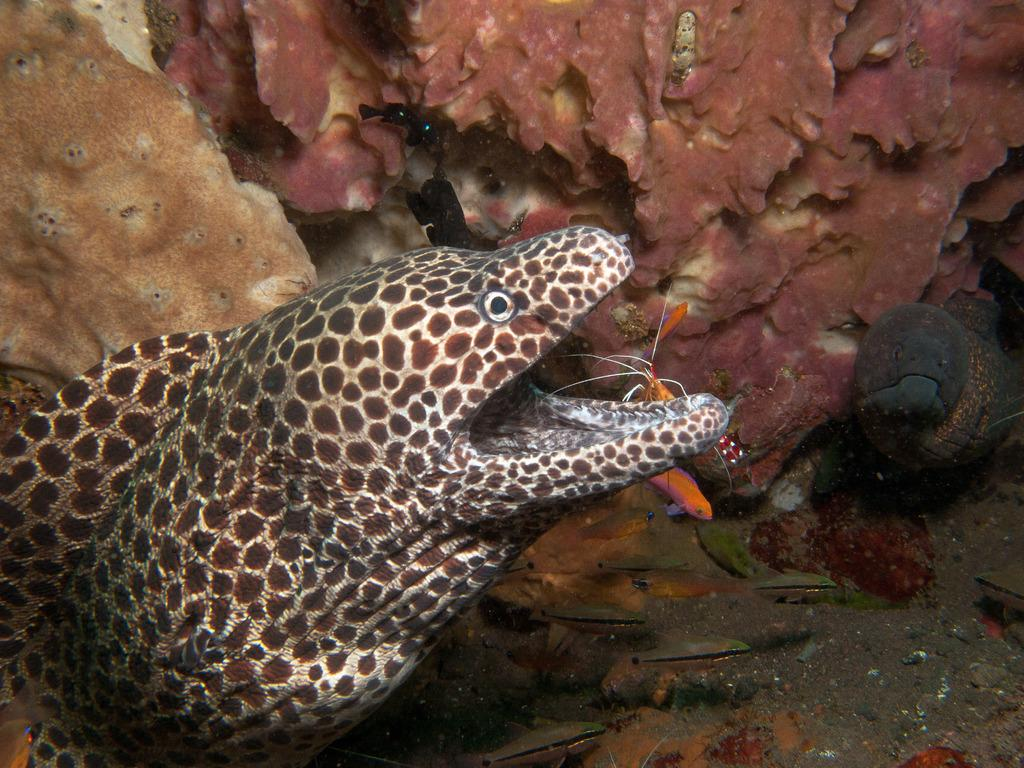What type of environment is depicted in the image? The image depicts an underwater environment. What type of marine life can be seen in the image? There are fishes in the image. Are there any other animals present in the underwater environment? Yes, there are other animals present in the underwater environment. What shape is the porter carrying in the image? There is no porter present in the image, as it depicts an underwater environment. 